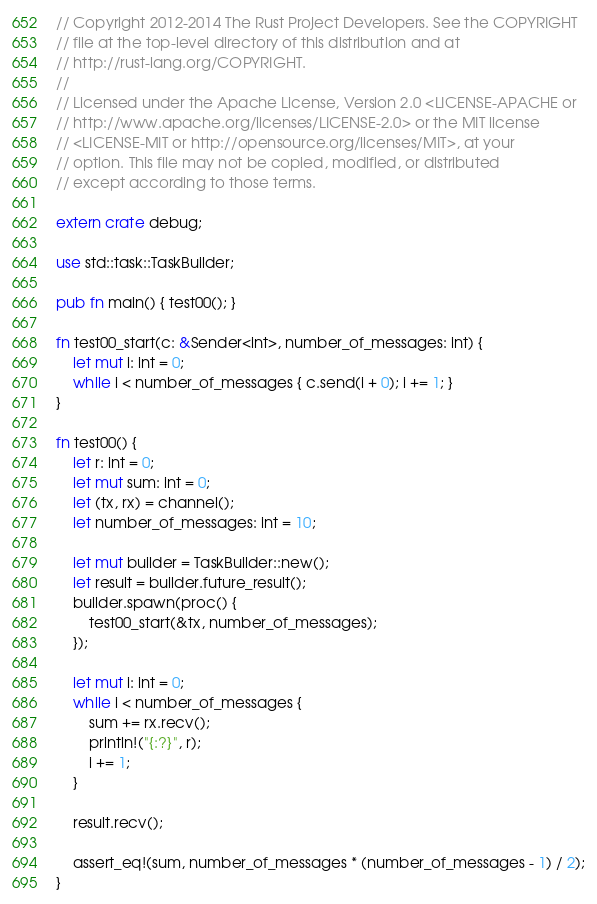Convert code to text. <code><loc_0><loc_0><loc_500><loc_500><_Rust_>// Copyright 2012-2014 The Rust Project Developers. See the COPYRIGHT
// file at the top-level directory of this distribution and at
// http://rust-lang.org/COPYRIGHT.
//
// Licensed under the Apache License, Version 2.0 <LICENSE-APACHE or
// http://www.apache.org/licenses/LICENSE-2.0> or the MIT license
// <LICENSE-MIT or http://opensource.org/licenses/MIT>, at your
// option. This file may not be copied, modified, or distributed
// except according to those terms.

extern crate debug;

use std::task::TaskBuilder;

pub fn main() { test00(); }

fn test00_start(c: &Sender<int>, number_of_messages: int) {
    let mut i: int = 0;
    while i < number_of_messages { c.send(i + 0); i += 1; }
}

fn test00() {
    let r: int = 0;
    let mut sum: int = 0;
    let (tx, rx) = channel();
    let number_of_messages: int = 10;

    let mut builder = TaskBuilder::new();
    let result = builder.future_result();
    builder.spawn(proc() {
        test00_start(&tx, number_of_messages);
    });

    let mut i: int = 0;
    while i < number_of_messages {
        sum += rx.recv();
        println!("{:?}", r);
        i += 1;
    }

    result.recv();

    assert_eq!(sum, number_of_messages * (number_of_messages - 1) / 2);
}
</code> 